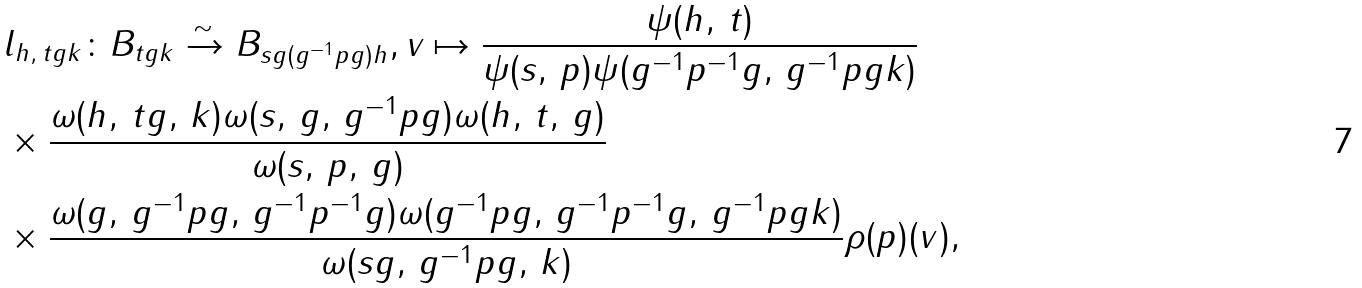<formula> <loc_0><loc_0><loc_500><loc_500>& l _ { h , \, t g k } \colon B _ { t g k } \xrightarrow { \sim } B _ { s g ( g ^ { - 1 } p g ) h } , v \mapsto \frac { \psi ( h , \, t ) } { \psi ( s , \, p ) \psi ( g ^ { - 1 } p ^ { - 1 } g , \, g ^ { - 1 } p g k ) } \\ & \times \frac { \omega ( h , \, t g , \, k ) \omega ( s , \, g , \, g ^ { - 1 } p g ) \omega ( h , \, t , \, g ) } { \omega ( s , \, p , \, g ) } \\ & \times \frac { \omega ( g , \, g ^ { - 1 } p g , \, g ^ { - 1 } p ^ { - 1 } g ) \omega ( g ^ { - 1 } p g , \, g ^ { - 1 } p ^ { - 1 } g , \, g ^ { - 1 } p g k ) } { \omega ( s g , \, g ^ { - 1 } p g , \, k ) } \rho ( p ) ( v ) ,</formula> 